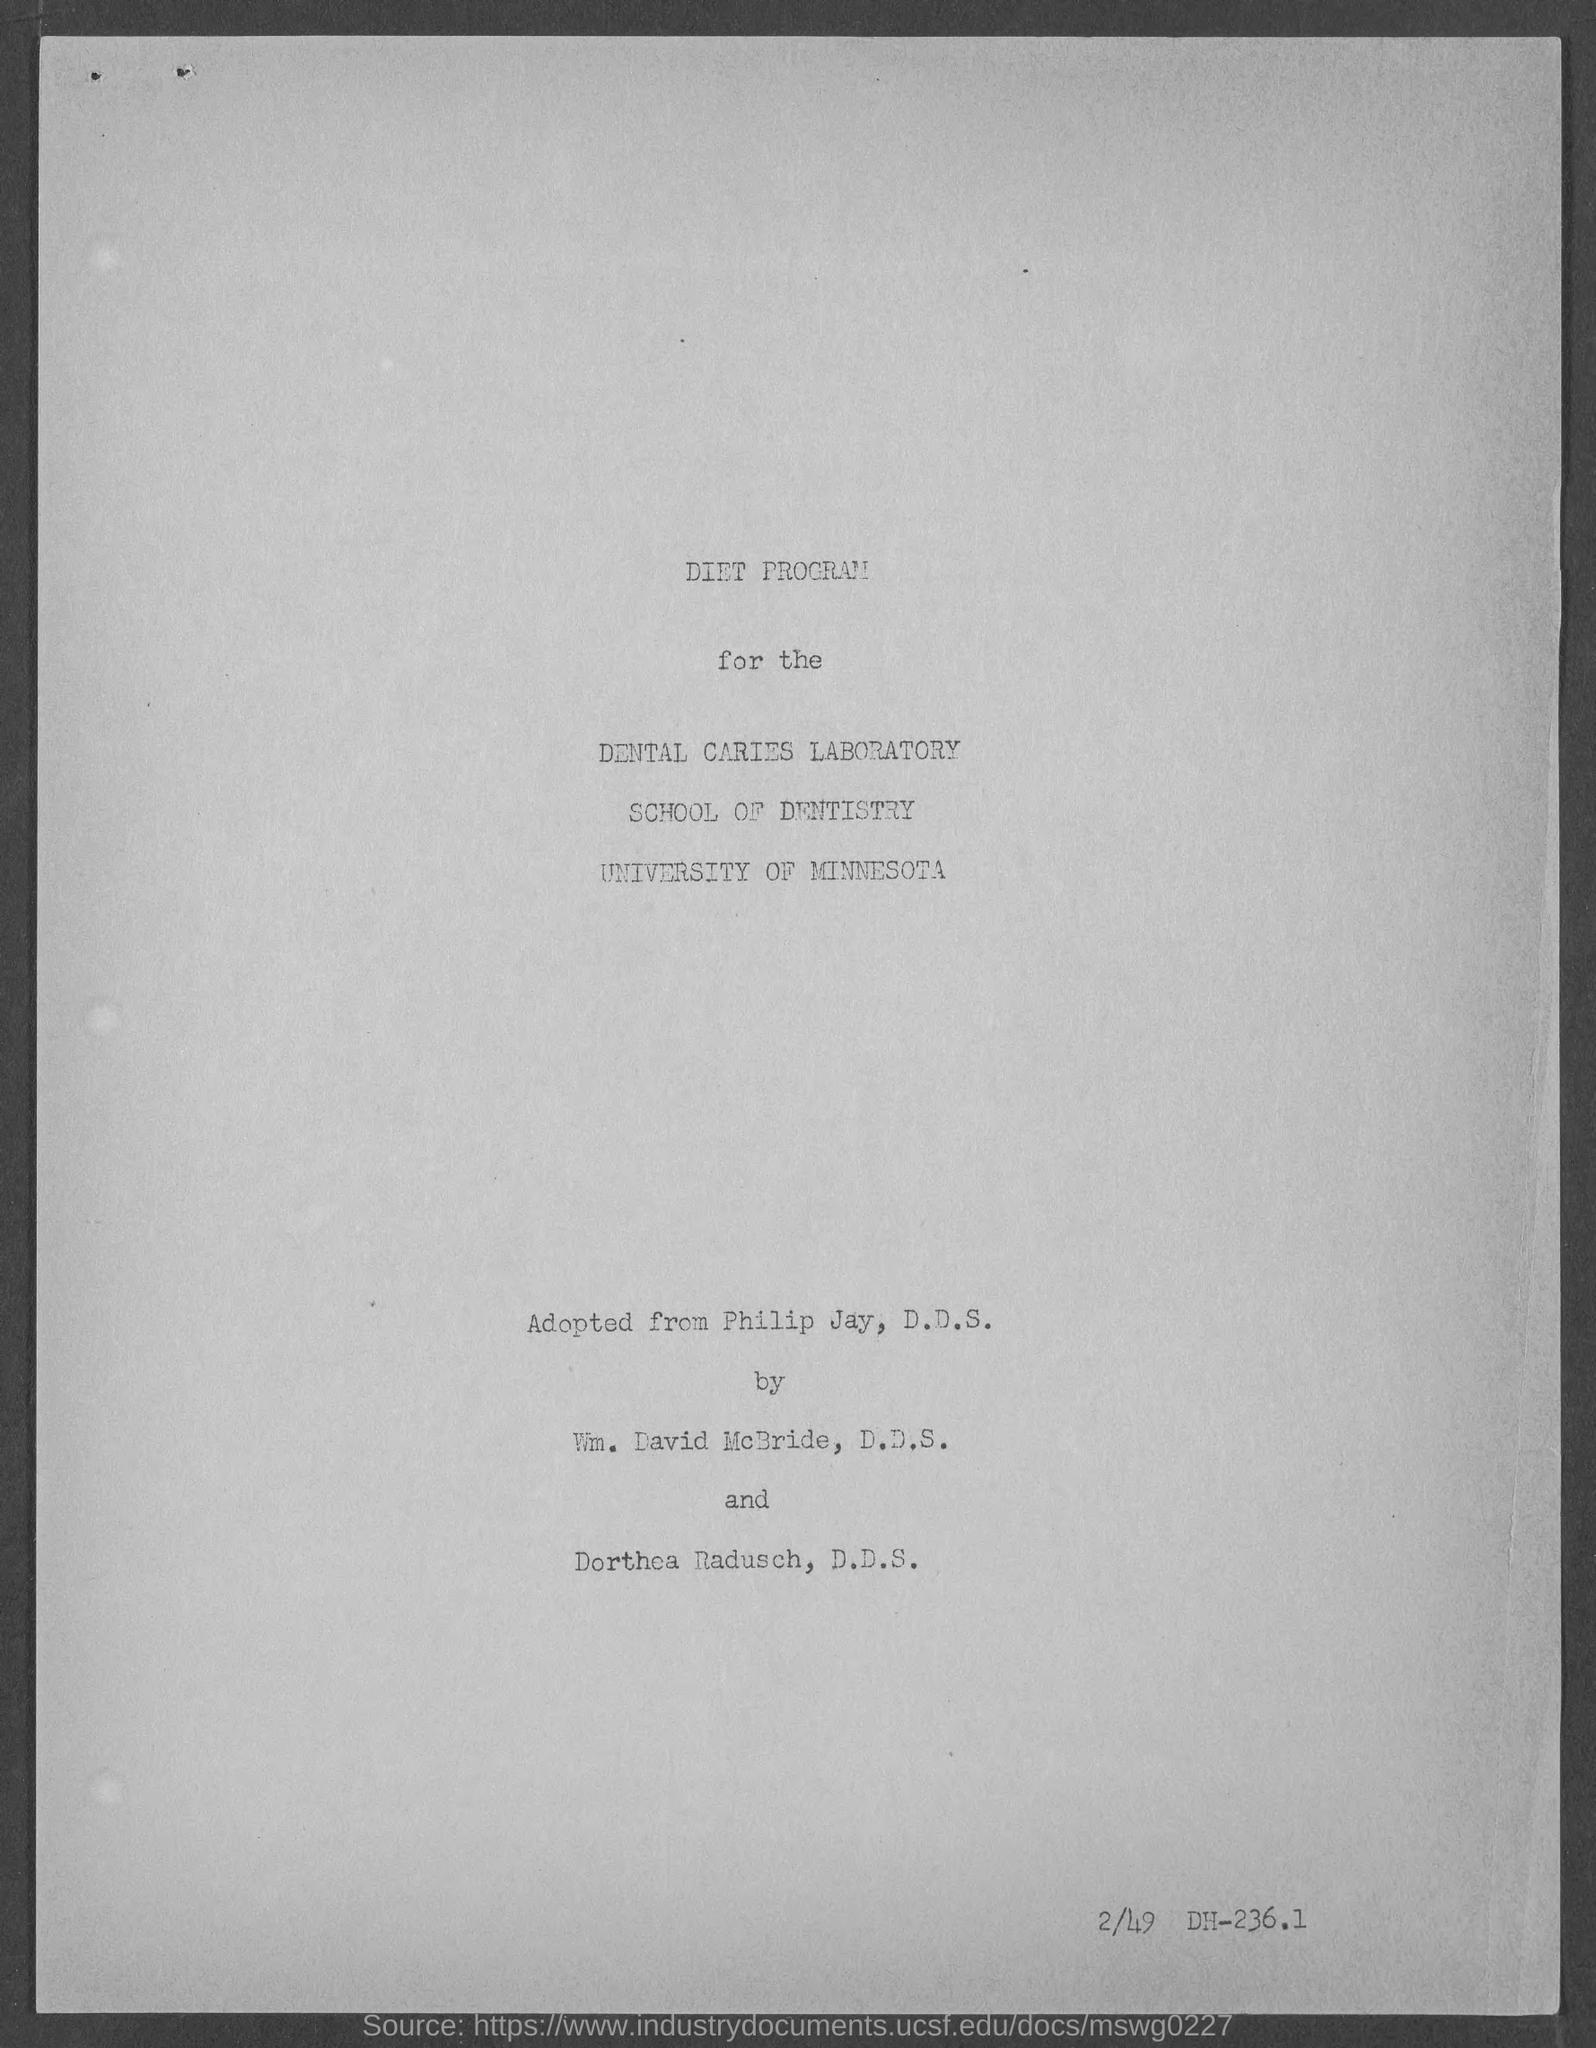List a handful of essential elements in this visual. The bottom right side contains the written text 2/49 DH-236.1. The School of Dentistry is part of the University of Minnesota. 